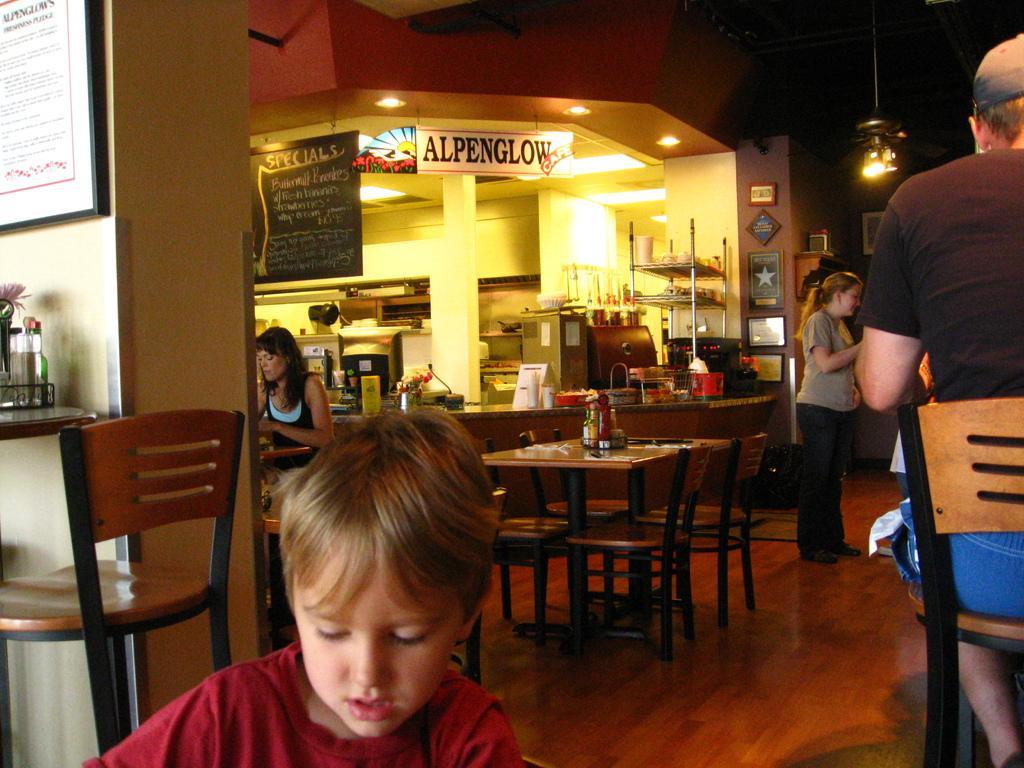In one or two sentences, can you explain what this image depicts? In the image there is a boy in front and there are tables and chairs in the middle,it seems to be of hotel,there is a woman stood at right side corner and over the ceiling there are some lights and there are some posters,banners with text on it. 